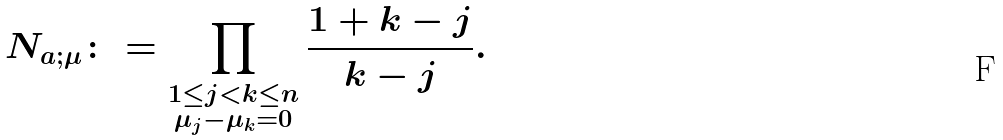<formula> <loc_0><loc_0><loc_500><loc_500>N _ { a ; \mu } \colon = \prod _ { \substack { 1 \leq j < k \leq n \\ \mu _ { j } - \mu _ { k } = 0 } } \frac { 1 + k - j } { k - j } .</formula> 